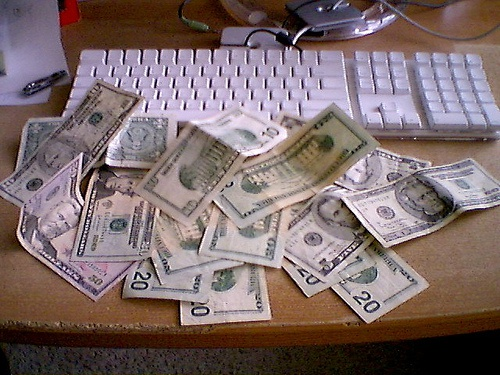Describe the objects in this image and their specific colors. I can see a keyboard in gray, darkgray, and lavender tones in this image. 